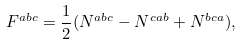<formula> <loc_0><loc_0><loc_500><loc_500>F ^ { a b c } = \frac { 1 } { 2 } ( N ^ { a b c } - N ^ { c a b } + N ^ { b c a } ) ,</formula> 